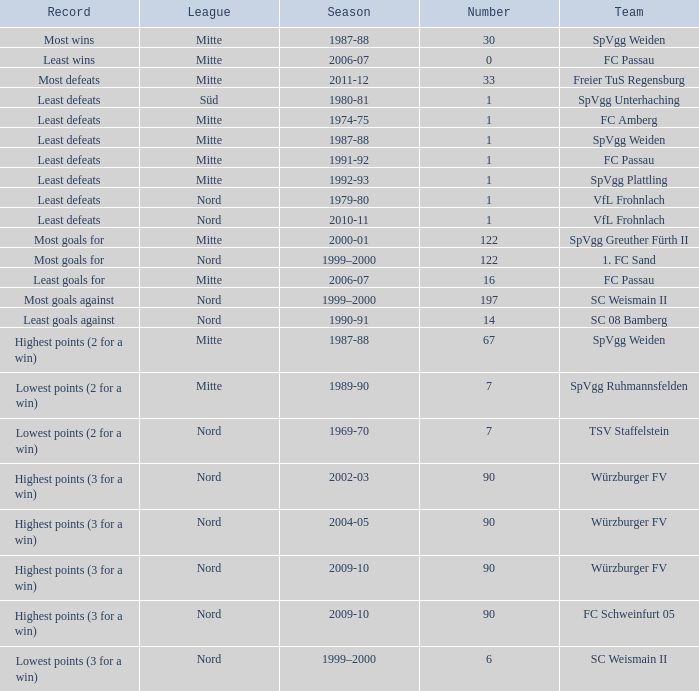What team has 2000-01 as the season? SpVgg Greuther Fürth II. 